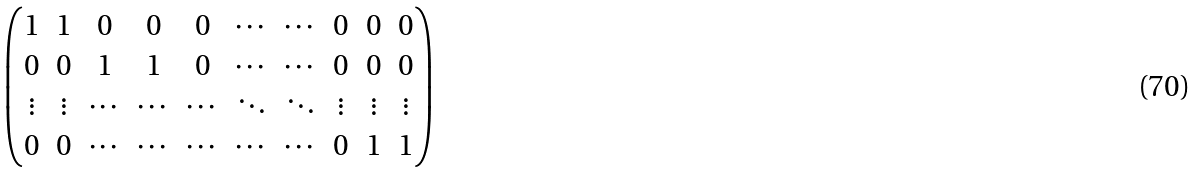<formula> <loc_0><loc_0><loc_500><loc_500>\begin{pmatrix} 1 & 1 & 0 & 0 & 0 & \cdots & \cdots & 0 & 0 & 0 \\ 0 & 0 & 1 & 1 & 0 & \cdots & \cdots & 0 & 0 & 0 \\ \vdots & \vdots & \cdots & \cdots & \cdots & \ddots & \ddots & \vdots & \vdots & \vdots \\ 0 & 0 & \cdots & \cdots & \cdots & \cdots & \cdots & 0 & 1 & 1 \end{pmatrix}</formula> 